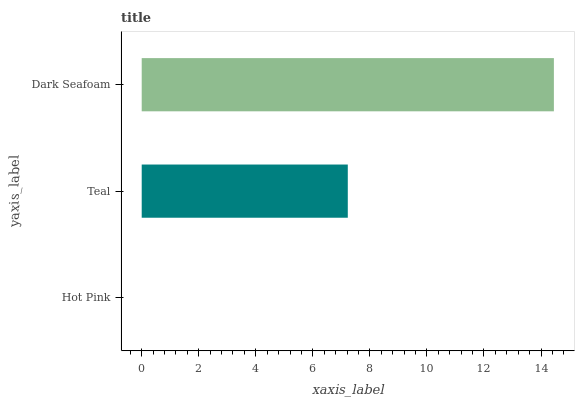Is Hot Pink the minimum?
Answer yes or no. Yes. Is Dark Seafoam the maximum?
Answer yes or no. Yes. Is Teal the minimum?
Answer yes or no. No. Is Teal the maximum?
Answer yes or no. No. Is Teal greater than Hot Pink?
Answer yes or no. Yes. Is Hot Pink less than Teal?
Answer yes or no. Yes. Is Hot Pink greater than Teal?
Answer yes or no. No. Is Teal less than Hot Pink?
Answer yes or no. No. Is Teal the high median?
Answer yes or no. Yes. Is Teal the low median?
Answer yes or no. Yes. Is Hot Pink the high median?
Answer yes or no. No. Is Hot Pink the low median?
Answer yes or no. No. 